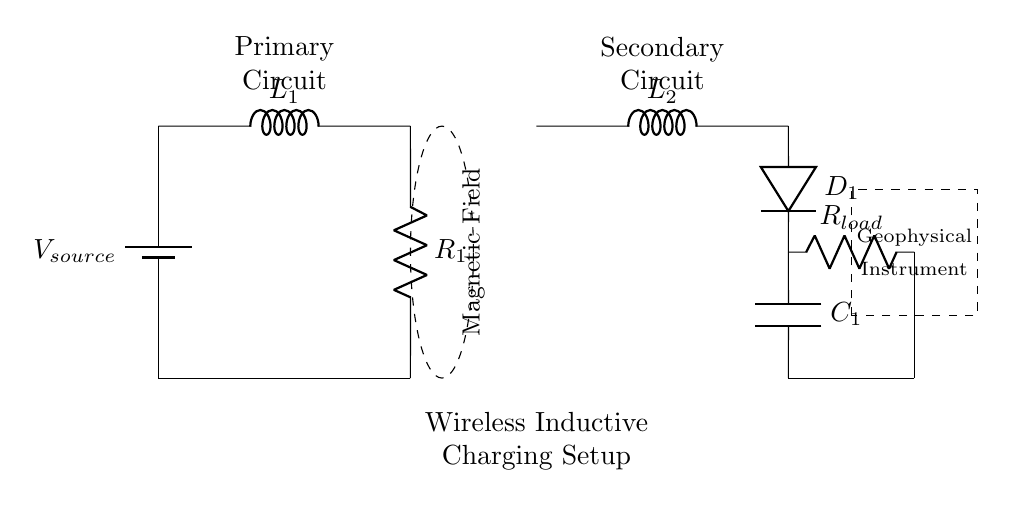What type of charging setup is depicted in the circuit? The circuit diagram represents a wireless inductive charging setup, which utilizes coils to transfer energy through a magnetic field.
Answer: Wireless inductive charging What are the two main coils in the circuit called? The two main coils in the circuit are known as the primary coil and the secondary coil. The primary coil is labeled as L1 and the secondary coil as L2.
Answer: L1 and L2 What is the role of the component labeled D1? The component labeled D1 is a diode, which allows current to flow in one direction, preventing backflow which ensures the circuit operates efficiently.
Answer: Diode Which component acts as the load in this circuit? The load in the circuit is represented by the resistor labeled R_load, which indicates the device drawing power from the circuitry.
Answer: R_load How does the magnetic field facilitate energy transfer in this circuit? The magnetic field, indicated by the dashed ellipse, allows energy to be transferred between the primary coil (L1) and the secondary coil (L2) without physical connection, utilizing electromagnetic induction principles.
Answer: Electromagnetic induction What purpose does the capacitor labeled C1 serve? The capacitor labeled C1 serves to store energy temporarily and filter voltage fluctuations in the secondary circuit, ensuring stable power delivery to the load.
Answer: Energy storage and filtering What is the relationship between the resistances R1 and R_load in terms of power loss? The resistances R1 and R_load are part of a series connection affecting the total resistance; higher resistance causes more power loss in the form of heat and less power available to the load.
Answer: Power loss increases with resistance 